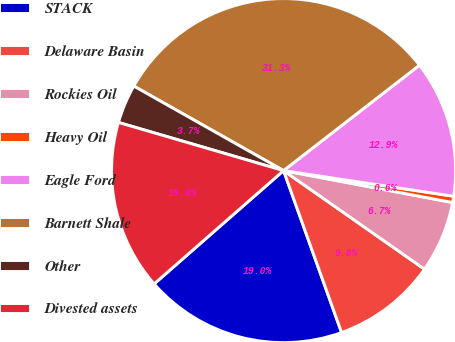Convert chart to OTSL. <chart><loc_0><loc_0><loc_500><loc_500><pie_chart><fcel>STACK<fcel>Delaware Basin<fcel>Rockies Oil<fcel>Heavy Oil<fcel>Eagle Ford<fcel>Barnett Shale<fcel>Other<fcel>Divested assets<nl><fcel>19.03%<fcel>9.81%<fcel>6.74%<fcel>0.59%<fcel>12.88%<fcel>31.32%<fcel>3.66%<fcel>15.96%<nl></chart> 